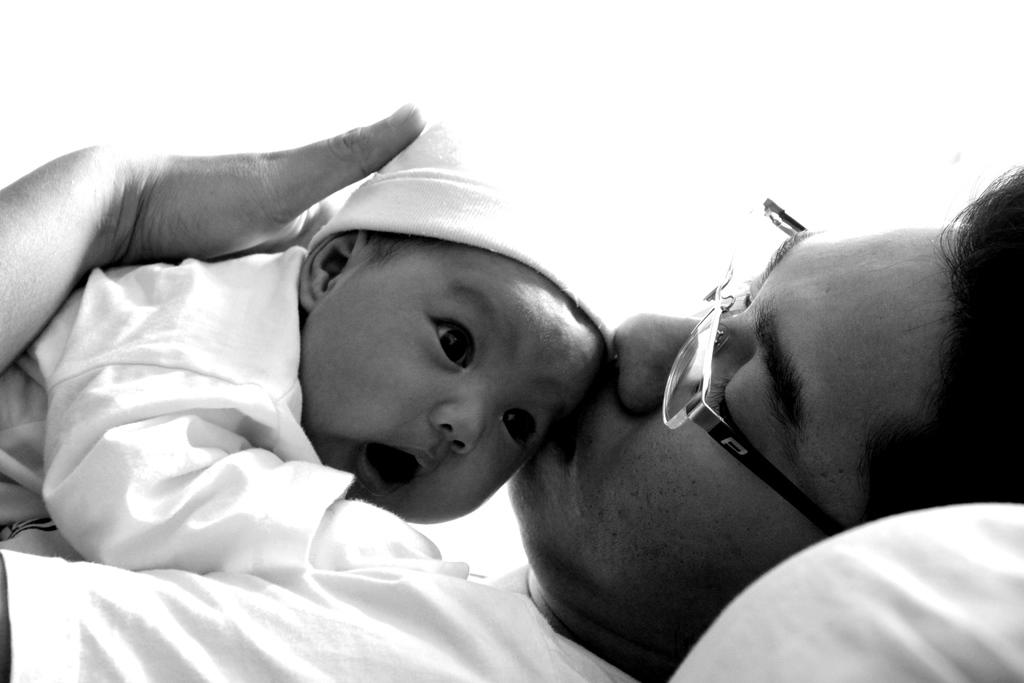What is the color scheme of the image? The image is black and white. Can you describe the main subject in the image? There is a person in the image. What is the person doing in the image? The person is holding a baby and kissing the baby. What type of pipe can be seen in the image? There is no pipe present in the image. Is there any indication of a spark in the image? There is no spark present in the image. 